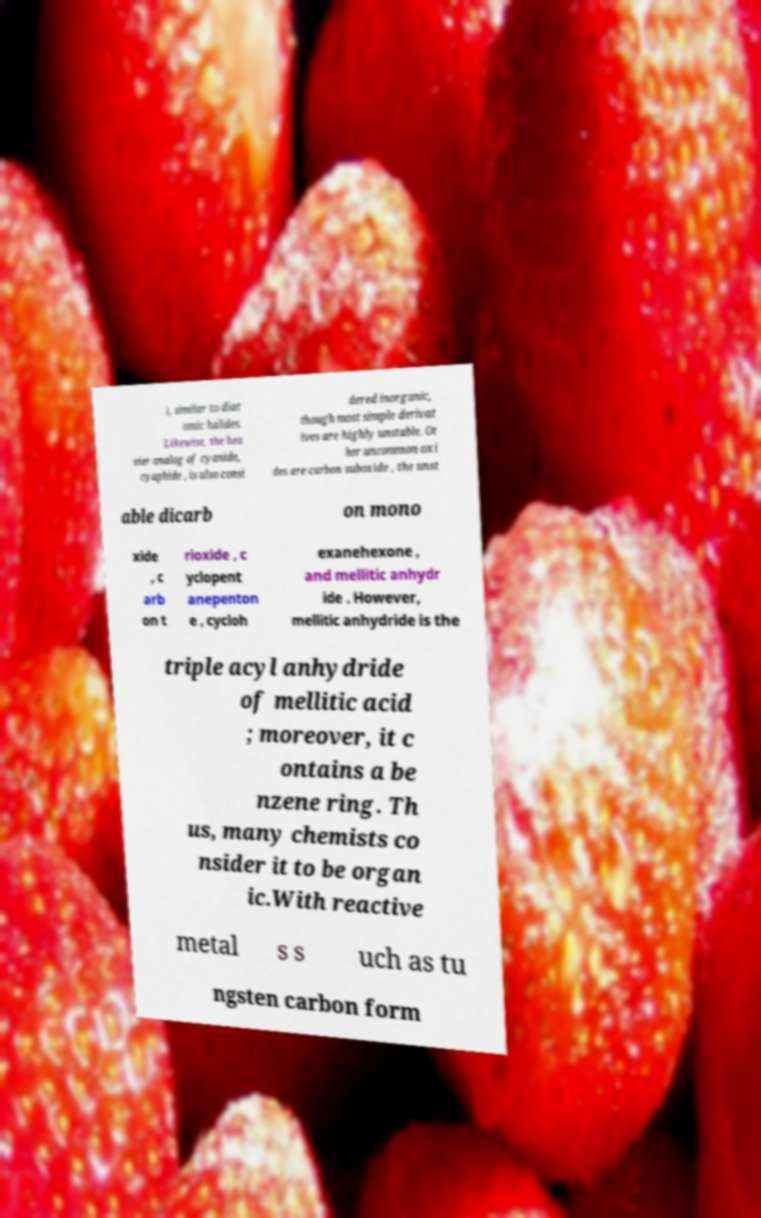Please identify and transcribe the text found in this image. ), similar to diat omic halides. Likewise, the hea vier analog of cyanide, cyaphide , is also consi dered inorganic, though most simple derivat ives are highly unstable. Ot her uncommon oxi des are carbon suboxide , the unst able dicarb on mono xide , c arb on t rioxide , c yclopent anepenton e , cycloh exanehexone , and mellitic anhydr ide . However, mellitic anhydride is the triple acyl anhydride of mellitic acid ; moreover, it c ontains a be nzene ring. Th us, many chemists co nsider it to be organ ic.With reactive metal s s uch as tu ngsten carbon form 